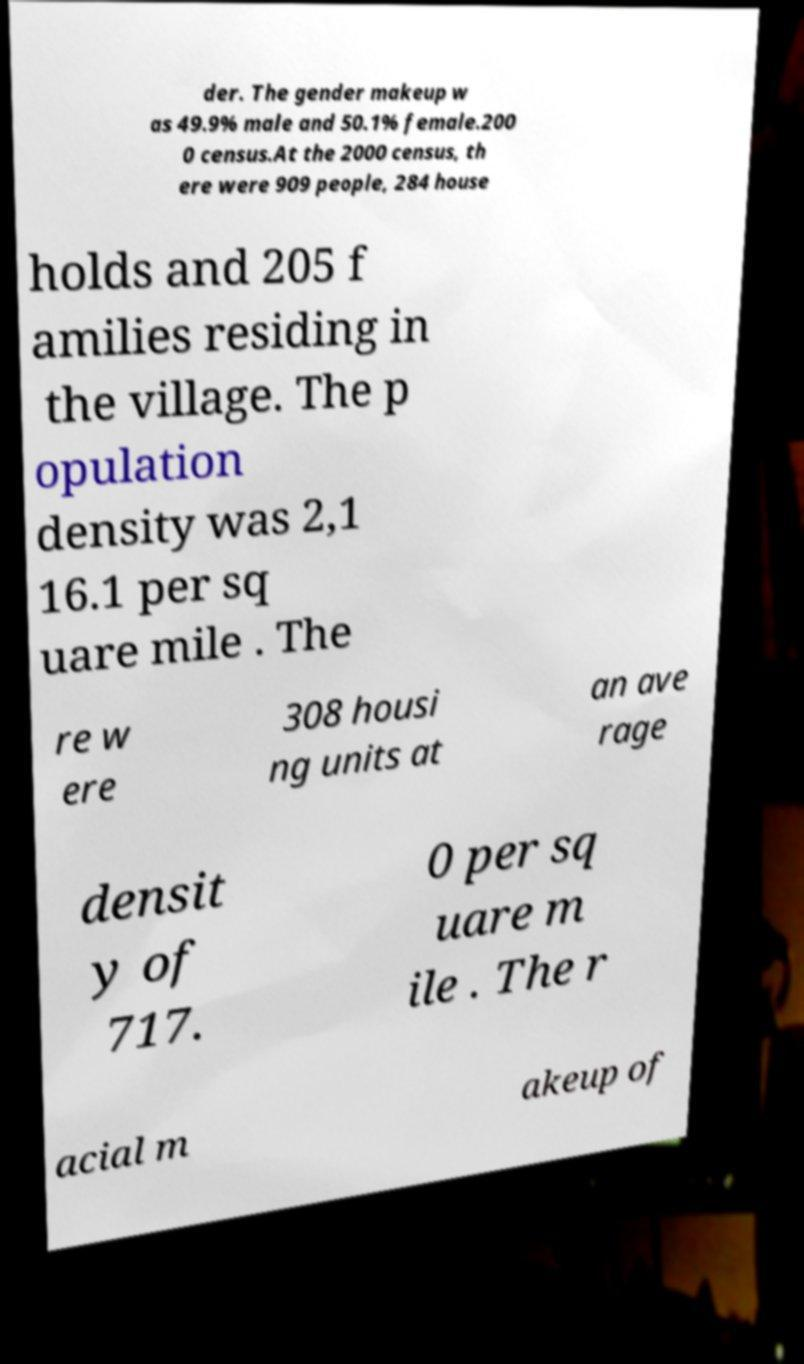Can you accurately transcribe the text from the provided image for me? der. The gender makeup w as 49.9% male and 50.1% female.200 0 census.At the 2000 census, th ere were 909 people, 284 house holds and 205 f amilies residing in the village. The p opulation density was 2,1 16.1 per sq uare mile . The re w ere 308 housi ng units at an ave rage densit y of 717. 0 per sq uare m ile . The r acial m akeup of 